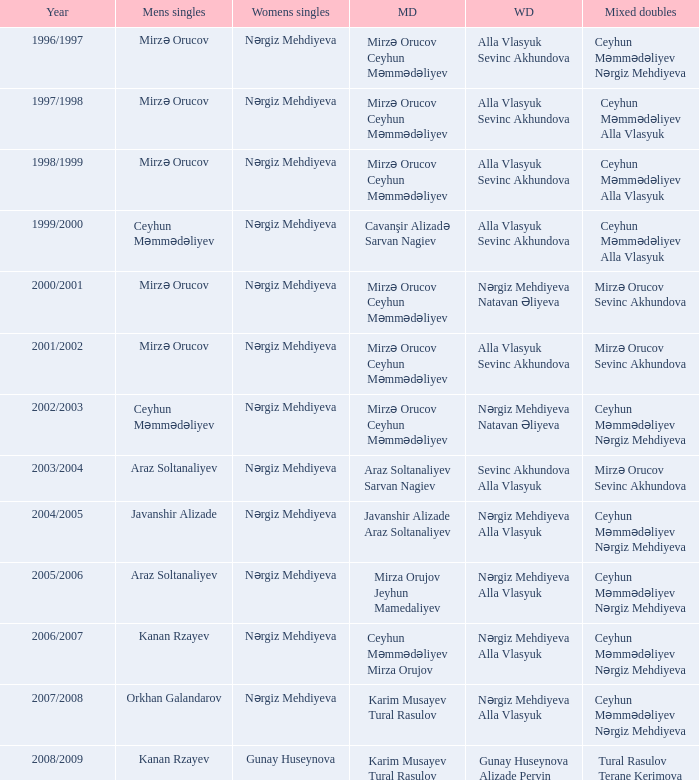Who are all the womens doubles for the year 2008/2009? Gunay Huseynova Alizade Pervin. 